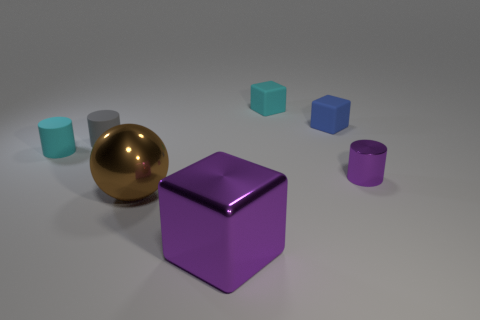The small shiny thing has what color? purple 